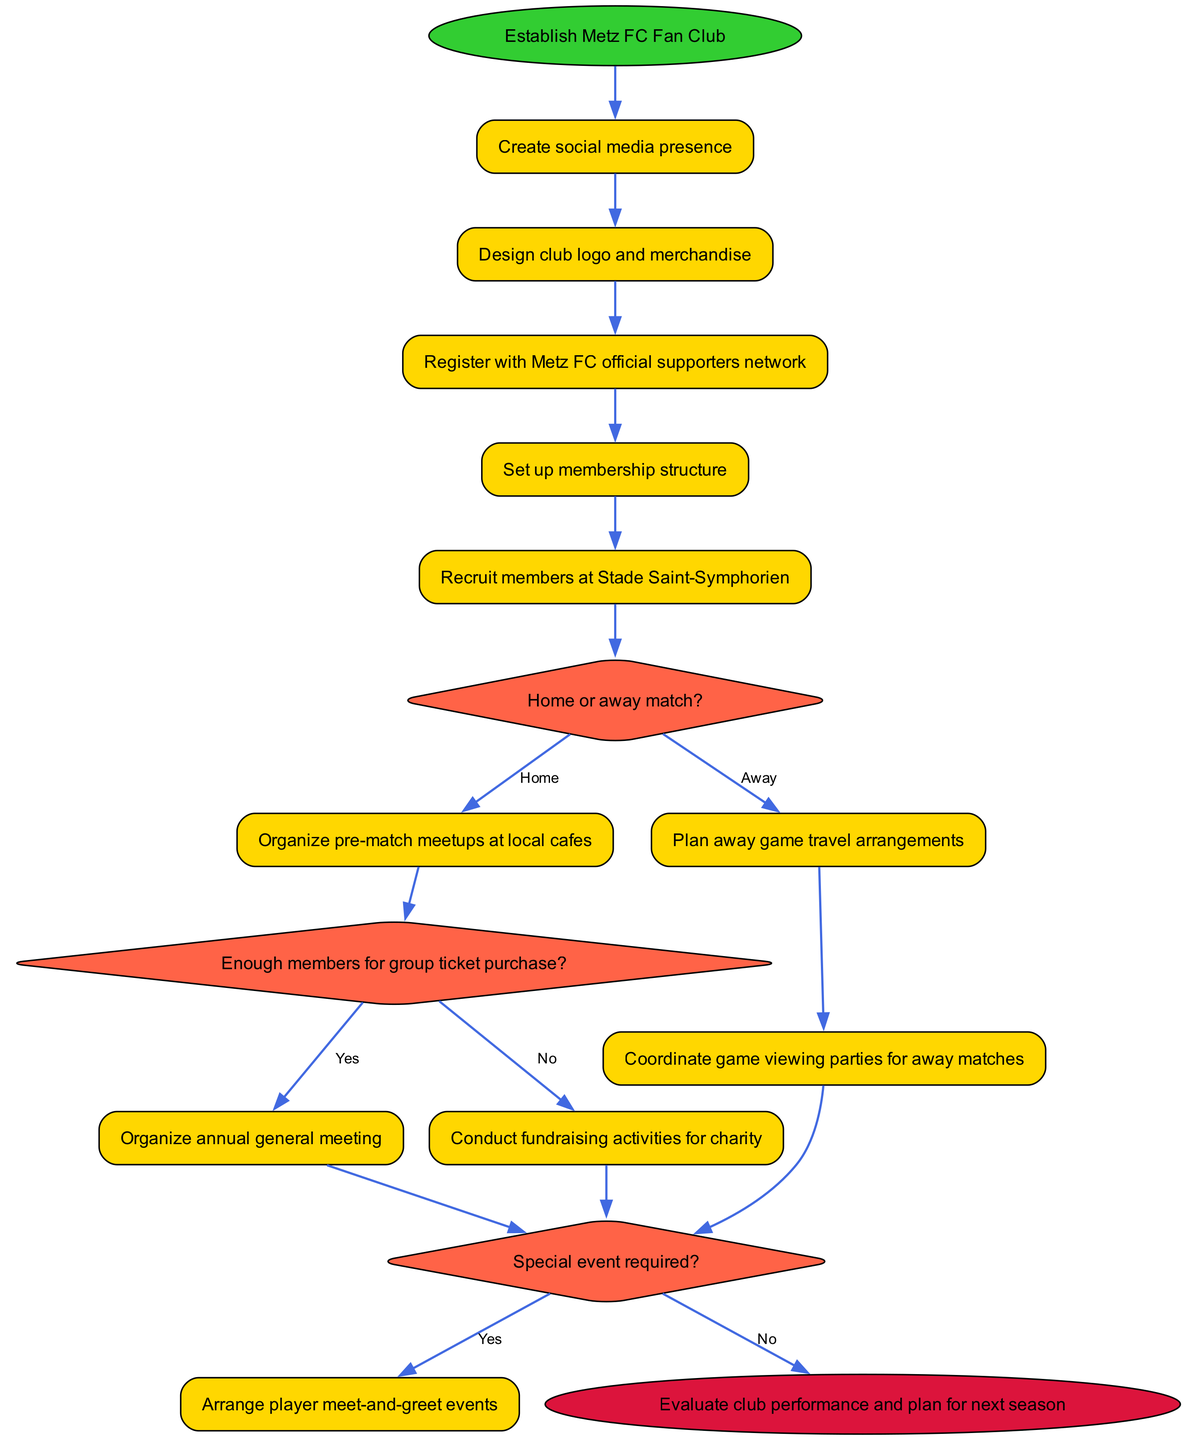What is the initial activity for establishing the Metz FC Fan Club? The initial node in the diagram clearly states "Establish Metz FC Fan Club" as the starting point of the activities.
Answer: Establish Metz FC Fan Club How many activities are listed in the diagram? By counting the entries in the "activities" section of the diagram data, there are 11 activities specified.
Answer: 11 What decision involves whether to arrange a special event or not? The decision node labeled "Special event required?" indicates the need to determine if a special event should be organized as part of the club activities.
Answer: Special event required? Which activity follows the decision for a home match? After the decision "Home or away match?", if the choice is "Home", the next activity in the sequence is "Organize pre-match meetups at local cafes."
Answer: Organize pre-match meetups at local cafes What happens if there are enough members for group ticket purchase? The diagram indicates that if the decision for group ticket purchase is "Yes", then the next activity is to "Organize annual general meeting."
Answer: Organize annual general meeting What is the last step in the process as per the diagram? The final node indicates that the last action in the activity sequence is to "Evaluate club performance and plan for next season."
Answer: Evaluate club performance and plan for next season What is one of the activities related to away matches? The diagram specifically includes the activity "Plan away game travel arrangements," which is focused on logistics for away games.
Answer: Plan away game travel arrangements In the case of an away match, which activity follows after planning travel arrangements? The flow shows that if the match is an away match, the next activity following "Plan away game travel arrangements" is "Coordinate game viewing parties for away matches."
Answer: Coordinate game viewing parties for away matches 